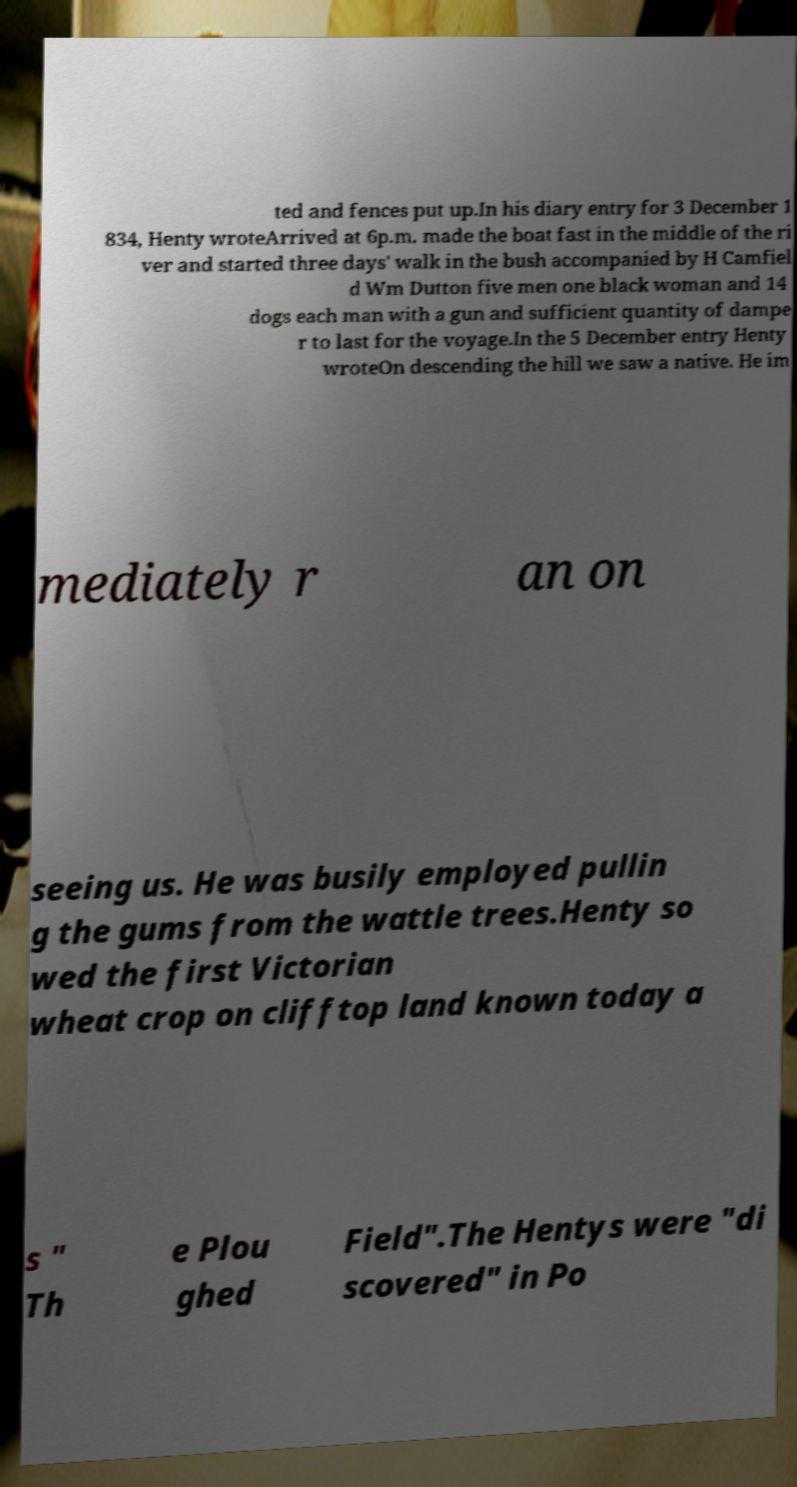Could you extract and type out the text from this image? ted and fences put up.In his diary entry for 3 December 1 834, Henty wroteArrived at 6p.m. made the boat fast in the middle of the ri ver and started three days' walk in the bush accompanied by H Camfiel d Wm Dutton five men one black woman and 14 dogs each man with a gun and sufficient quantity of dampe r to last for the voyage.In the 5 December entry Henty wroteOn descending the hill we saw a native. He im mediately r an on seeing us. He was busily employed pullin g the gums from the wattle trees.Henty so wed the first Victorian wheat crop on clifftop land known today a s " Th e Plou ghed Field".The Hentys were "di scovered" in Po 